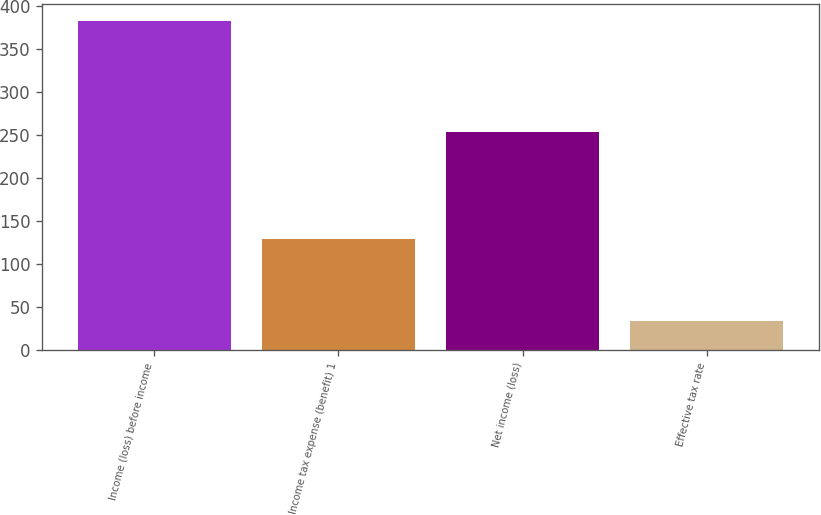<chart> <loc_0><loc_0><loc_500><loc_500><bar_chart><fcel>Income (loss) before income<fcel>Income tax expense (benefit) 1<fcel>Net income (loss)<fcel>Effective tax rate<nl><fcel>383<fcel>129<fcel>254<fcel>33.7<nl></chart> 